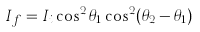Convert formula to latex. <formula><loc_0><loc_0><loc_500><loc_500>I _ { f } = I _ { i } \cos ^ { 2 } \theta _ { 1 } \cos ^ { 2 } ( \theta _ { 2 } - \theta _ { 1 } )</formula> 